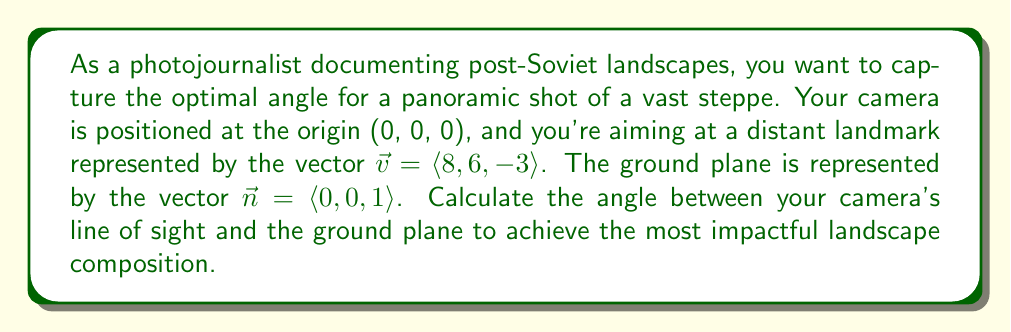Show me your answer to this math problem. To solve this problem, we'll use vector projection and the dot product formula. Here's a step-by-step approach:

1) The angle between the camera's line of sight ($\vec{v}$) and the ground plane ($\vec{n}$) is complementary to the angle we're looking for. Let's call our desired angle $\theta$.

2) We can find the complementary angle using the dot product formula:

   $$\cos(\frac{\pi}{2} - \theta) = \frac{\vec{v} \cdot \vec{n}}{|\vec{v}||\vec{n}|}$$

3) Calculate the dot product $\vec{v} \cdot \vec{n}$:
   $$\vec{v} \cdot \vec{n} = 8(0) + 6(0) + (-3)(1) = -3$$

4) Calculate the magnitudes:
   $$|\vec{v}| = \sqrt{8^2 + 6^2 + (-3)^2} = \sqrt{64 + 36 + 9} = \sqrt{109}$$
   $$|\vec{n}| = \sqrt{0^2 + 0^2 + 1^2} = 1$$

5) Substitute into the dot product formula:

   $$\cos(\frac{\pi}{2} - \theta) = \frac{-3}{\sqrt{109} \cdot 1} = \frac{-3}{\sqrt{109}}$$

6) To find $\theta$, we need to apply inverse cosine and subtract from $\frac{\pi}{2}$:

   $$\theta = \frac{\pi}{2} - \arccos(\frac{-3}{\sqrt{109}})$$

7) Convert to degrees:

   $$\theta = (90° - \arccos(\frac{-3}{\sqrt{109}}) \cdot \frac{180°}{\pi})°$$
Answer: $$(90° - \arccos(\frac{-3}{\sqrt{109}}) \cdot \frac{180°}{\pi})°$$ 